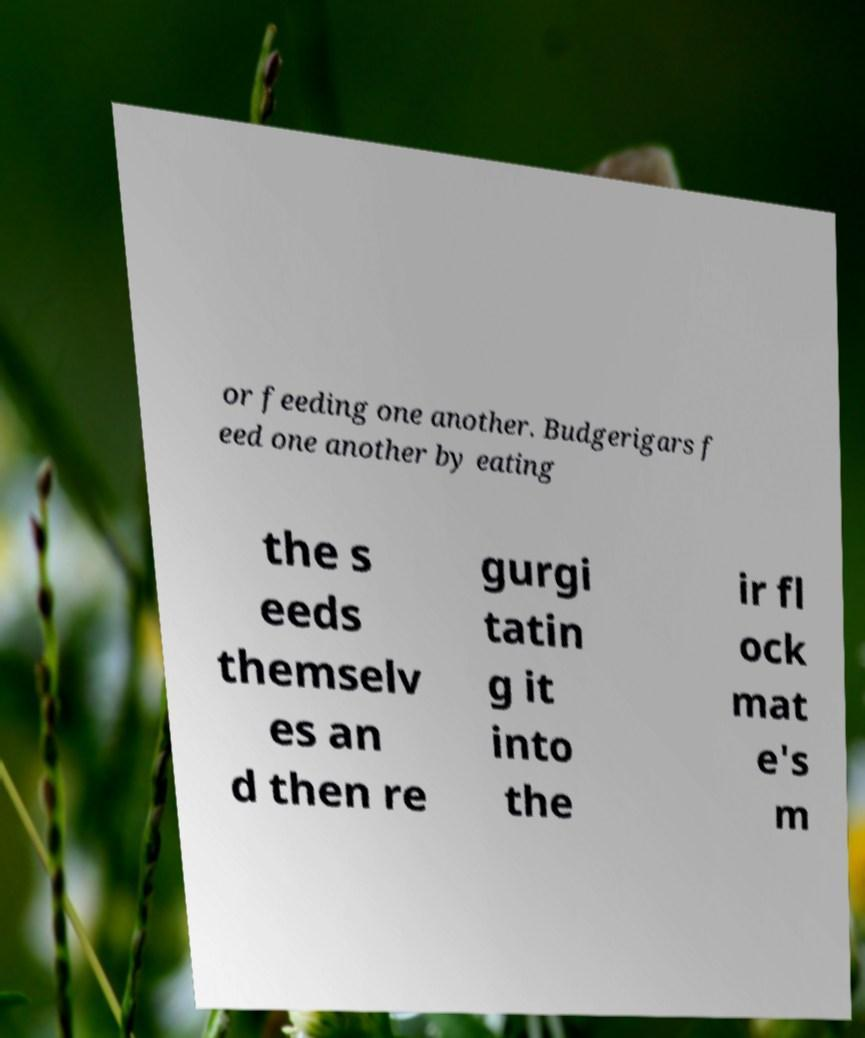Could you assist in decoding the text presented in this image and type it out clearly? or feeding one another. Budgerigars f eed one another by eating the s eeds themselv es an d then re gurgi tatin g it into the ir fl ock mat e's m 